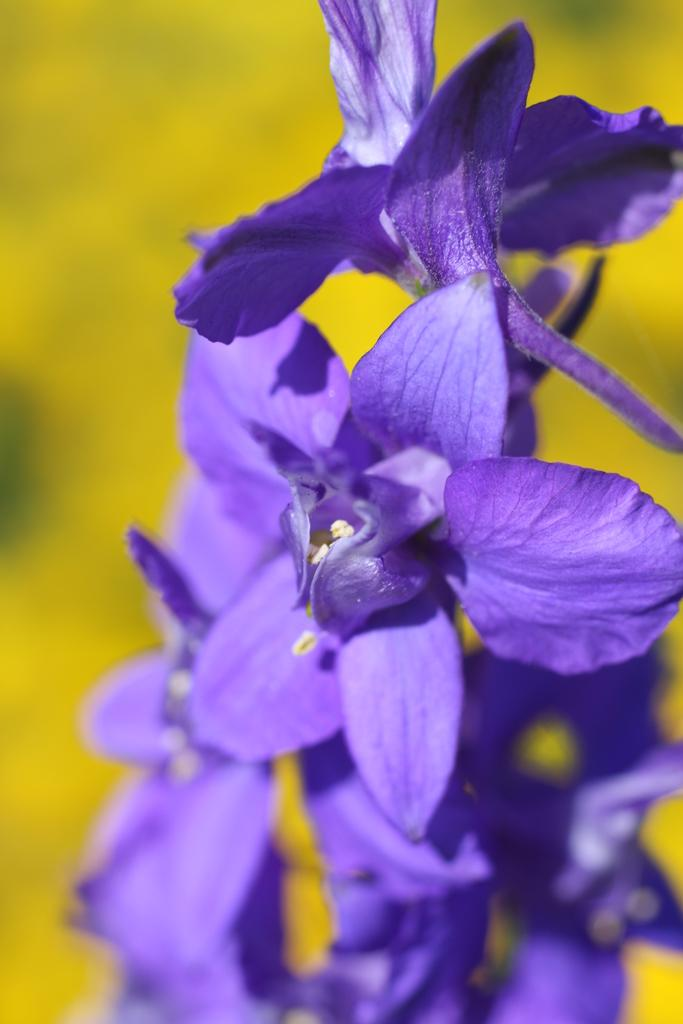What is located in the front of the image? There are flowers in the front of the image. Can you describe the background of the image? The background of the image is blurry. What type of horn can be seen on the airplane in the image? There is no airplane or horn present in the image; it features flowers in the front and a blurry background. 